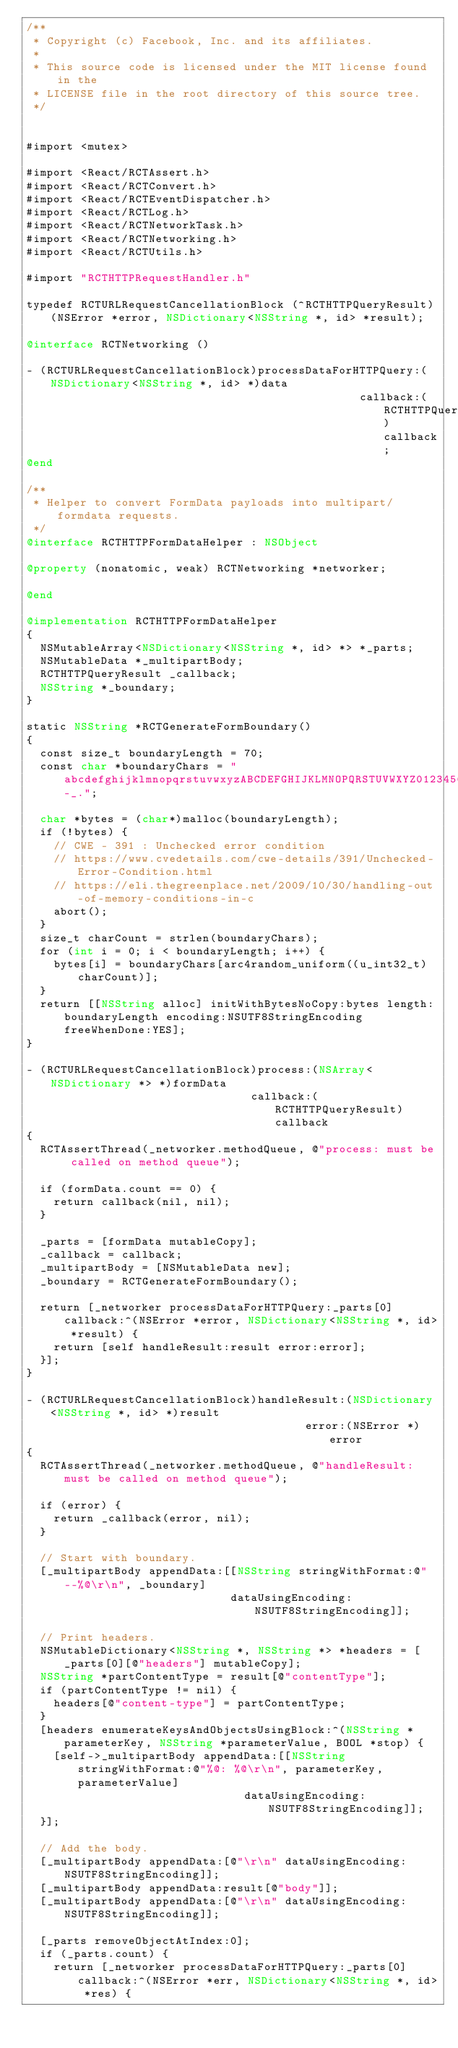<code> <loc_0><loc_0><loc_500><loc_500><_ObjectiveC_>/**
 * Copyright (c) Facebook, Inc. and its affiliates.
 *
 * This source code is licensed under the MIT license found in the
 * LICENSE file in the root directory of this source tree.
 */


#import <mutex>

#import <React/RCTAssert.h>
#import <React/RCTConvert.h>
#import <React/RCTEventDispatcher.h>
#import <React/RCTLog.h>
#import <React/RCTNetworkTask.h>
#import <React/RCTNetworking.h>
#import <React/RCTUtils.h>

#import "RCTHTTPRequestHandler.h"

typedef RCTURLRequestCancellationBlock (^RCTHTTPQueryResult)(NSError *error, NSDictionary<NSString *, id> *result);

@interface RCTNetworking ()

- (RCTURLRequestCancellationBlock)processDataForHTTPQuery:(NSDictionary<NSString *, id> *)data
                                                 callback:(RCTHTTPQueryResult)callback;
@end

/**
 * Helper to convert FormData payloads into multipart/formdata requests.
 */
@interface RCTHTTPFormDataHelper : NSObject

@property (nonatomic, weak) RCTNetworking *networker;

@end

@implementation RCTHTTPFormDataHelper
{
  NSMutableArray<NSDictionary<NSString *, id> *> *_parts;
  NSMutableData *_multipartBody;
  RCTHTTPQueryResult _callback;
  NSString *_boundary;
}

static NSString *RCTGenerateFormBoundary()
{
  const size_t boundaryLength = 70;
  const char *boundaryChars = "abcdefghijklmnopqrstuvwxyzABCDEFGHIJKLMNOPQRSTUVWXYZ0123456789-_.";

  char *bytes = (char*)malloc(boundaryLength);
  if (!bytes) {
    // CWE - 391 : Unchecked error condition
    // https://www.cvedetails.com/cwe-details/391/Unchecked-Error-Condition.html
    // https://eli.thegreenplace.net/2009/10/30/handling-out-of-memory-conditions-in-c
    abort();
  }
  size_t charCount = strlen(boundaryChars);
  for (int i = 0; i < boundaryLength; i++) {
    bytes[i] = boundaryChars[arc4random_uniform((u_int32_t)charCount)];
  }
  return [[NSString alloc] initWithBytesNoCopy:bytes length:boundaryLength encoding:NSUTF8StringEncoding freeWhenDone:YES];
}

- (RCTURLRequestCancellationBlock)process:(NSArray<NSDictionary *> *)formData
                                 callback:(RCTHTTPQueryResult)callback
{
  RCTAssertThread(_networker.methodQueue, @"process: must be called on method queue");

  if (formData.count == 0) {
    return callback(nil, nil);
  }

  _parts = [formData mutableCopy];
  _callback = callback;
  _multipartBody = [NSMutableData new];
  _boundary = RCTGenerateFormBoundary();

  return [_networker processDataForHTTPQuery:_parts[0] callback:^(NSError *error, NSDictionary<NSString *, id> *result) {
    return [self handleResult:result error:error];
  }];
}

- (RCTURLRequestCancellationBlock)handleResult:(NSDictionary<NSString *, id> *)result
                                         error:(NSError *)error
{
  RCTAssertThread(_networker.methodQueue, @"handleResult: must be called on method queue");

  if (error) {
    return _callback(error, nil);
  }

  // Start with boundary.
  [_multipartBody appendData:[[NSString stringWithFormat:@"--%@\r\n", _boundary]
                              dataUsingEncoding:NSUTF8StringEncoding]];

  // Print headers.
  NSMutableDictionary<NSString *, NSString *> *headers = [_parts[0][@"headers"] mutableCopy];
  NSString *partContentType = result[@"contentType"];
  if (partContentType != nil) {
    headers[@"content-type"] = partContentType;
  }
  [headers enumerateKeysAndObjectsUsingBlock:^(NSString *parameterKey, NSString *parameterValue, BOOL *stop) {
    [self->_multipartBody appendData:[[NSString stringWithFormat:@"%@: %@\r\n", parameterKey, parameterValue]
                                dataUsingEncoding:NSUTF8StringEncoding]];
  }];

  // Add the body.
  [_multipartBody appendData:[@"\r\n" dataUsingEncoding:NSUTF8StringEncoding]];
  [_multipartBody appendData:result[@"body"]];
  [_multipartBody appendData:[@"\r\n" dataUsingEncoding:NSUTF8StringEncoding]];

  [_parts removeObjectAtIndex:0];
  if (_parts.count) {
    return [_networker processDataForHTTPQuery:_parts[0] callback:^(NSError *err, NSDictionary<NSString *, id> *res) {</code> 